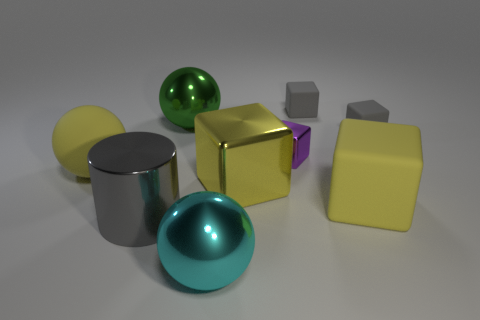Do the small metal thing that is behind the yellow metal object and the large shiny cube have the same color?
Provide a short and direct response. No. What number of cylinders are either large yellow metal things or green things?
Keep it short and to the point. 0. What is the size of the gray matte block that is right of the tiny gray matte block that is to the left of the yellow matte thing that is on the right side of the big yellow matte ball?
Your answer should be compact. Small. What is the shape of the green object that is the same size as the yellow matte ball?
Offer a very short reply. Sphere. The purple metal object has what shape?
Give a very brief answer. Cube. Are the sphere that is behind the yellow ball and the gray cylinder made of the same material?
Your answer should be compact. Yes. How big is the matte cube that is left of the big matte thing that is to the right of the big yellow rubber sphere?
Make the answer very short. Small. What color is the matte thing that is in front of the purple metal cube and right of the big green ball?
Your answer should be very brief. Yellow. What is the material of the cylinder that is the same size as the yellow shiny cube?
Ensure brevity in your answer.  Metal. How many other things are there of the same material as the big green object?
Keep it short and to the point. 4. 